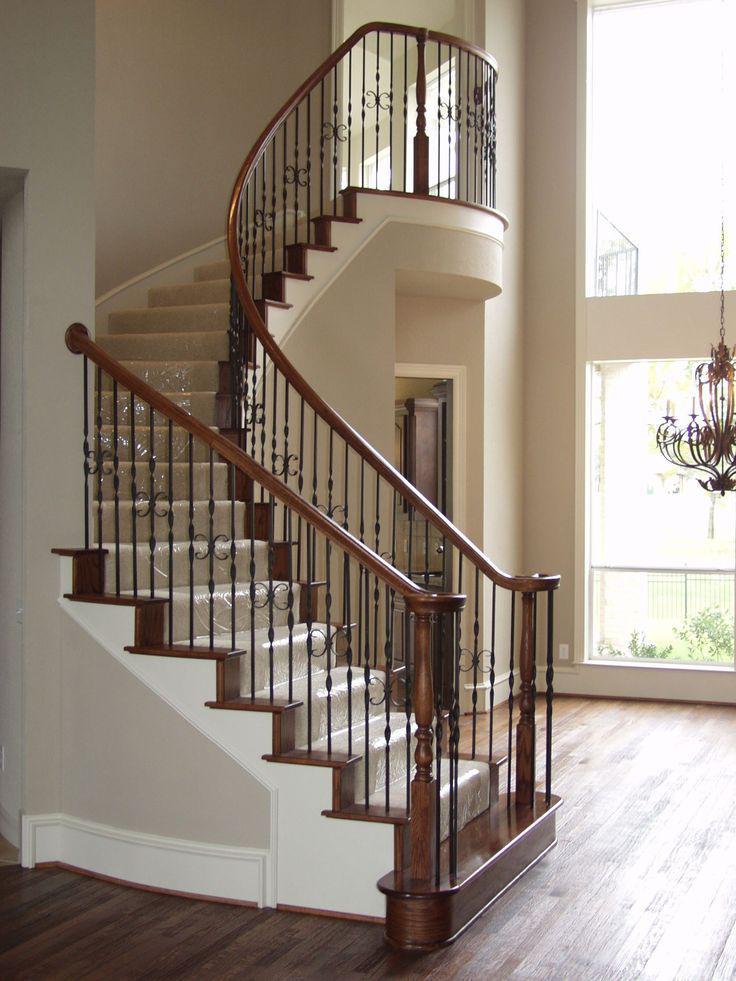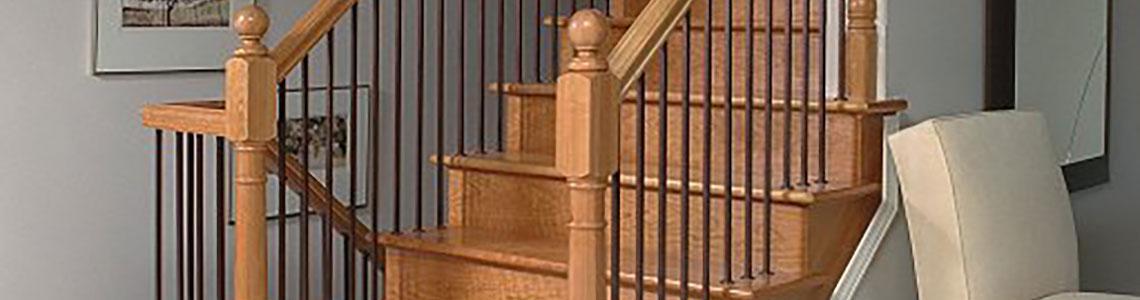The first image is the image on the left, the second image is the image on the right. Analyze the images presented: Is the assertion "There are at least four S shaped pieces of metal in the railing by the stairs." valid? Answer yes or no. No. 